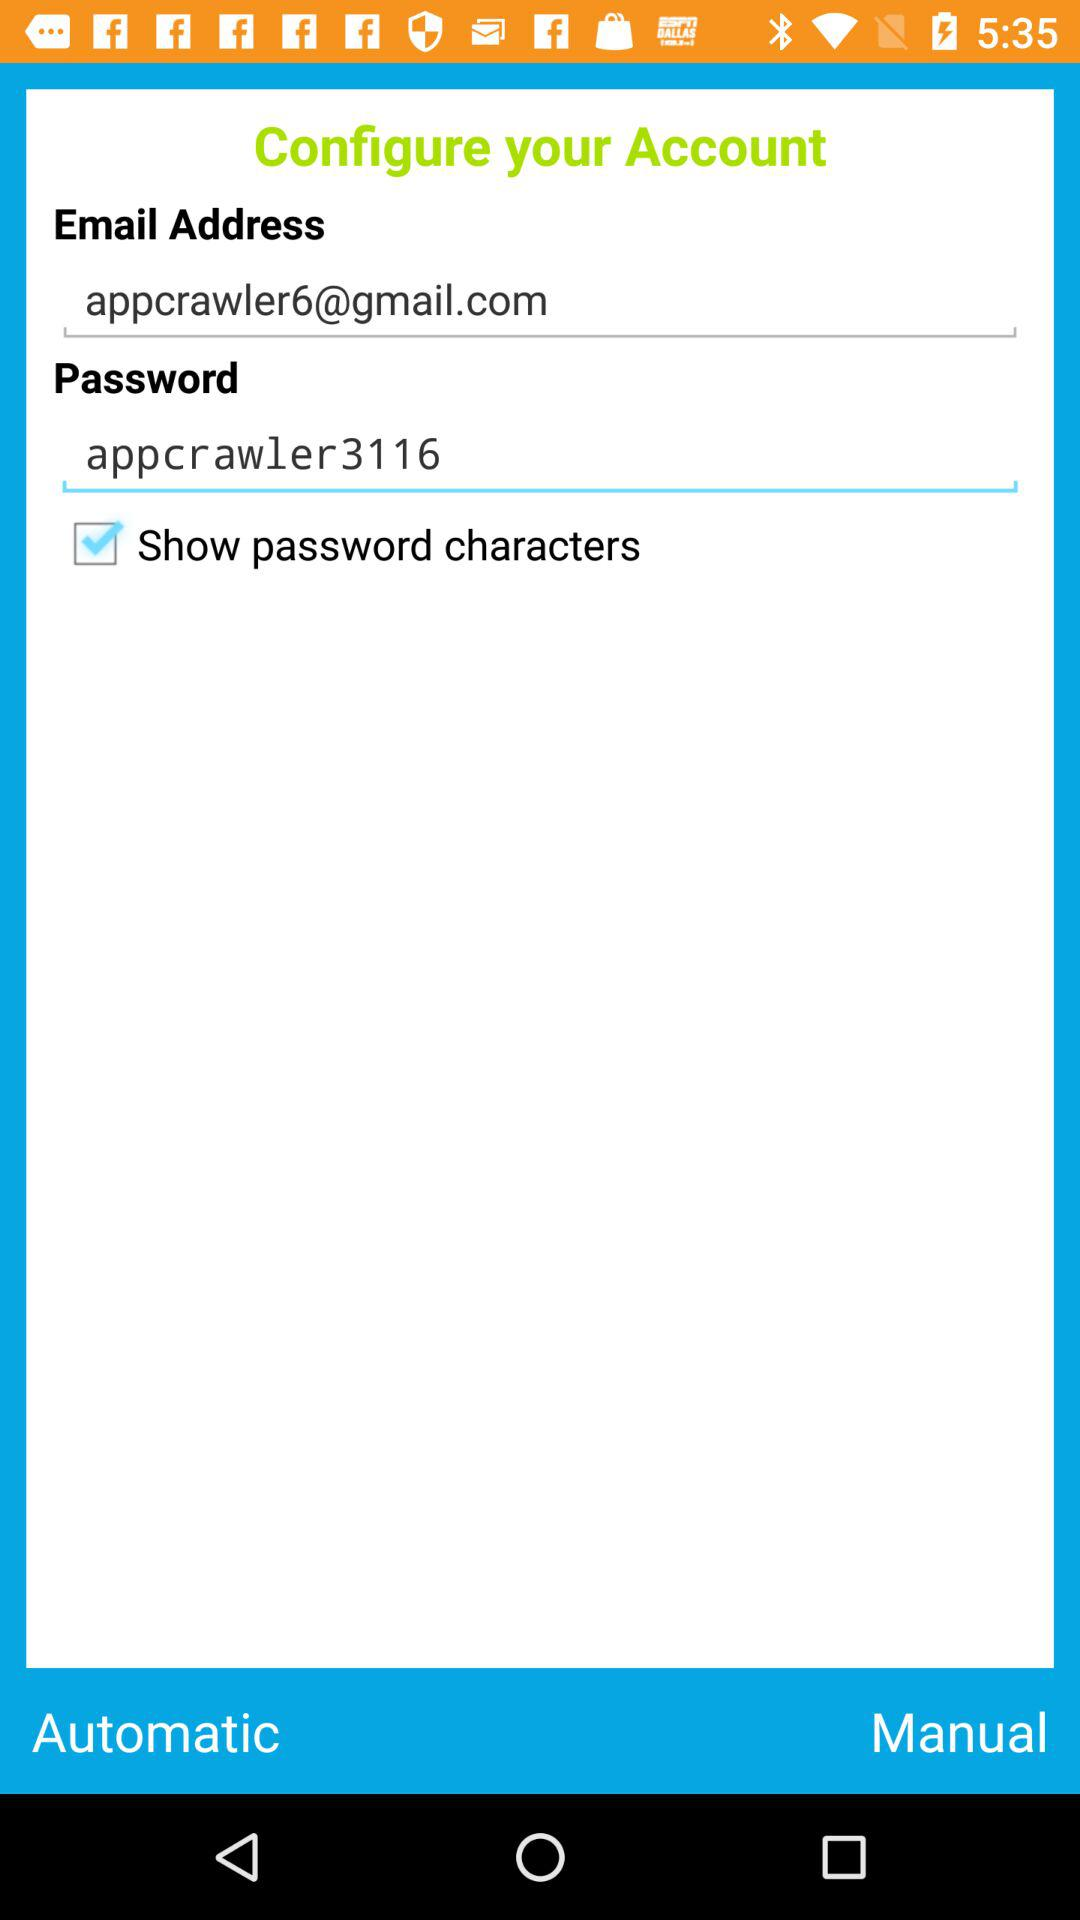What's the status of the "Show password characters"? The status of the "Show password characters" is "on". 